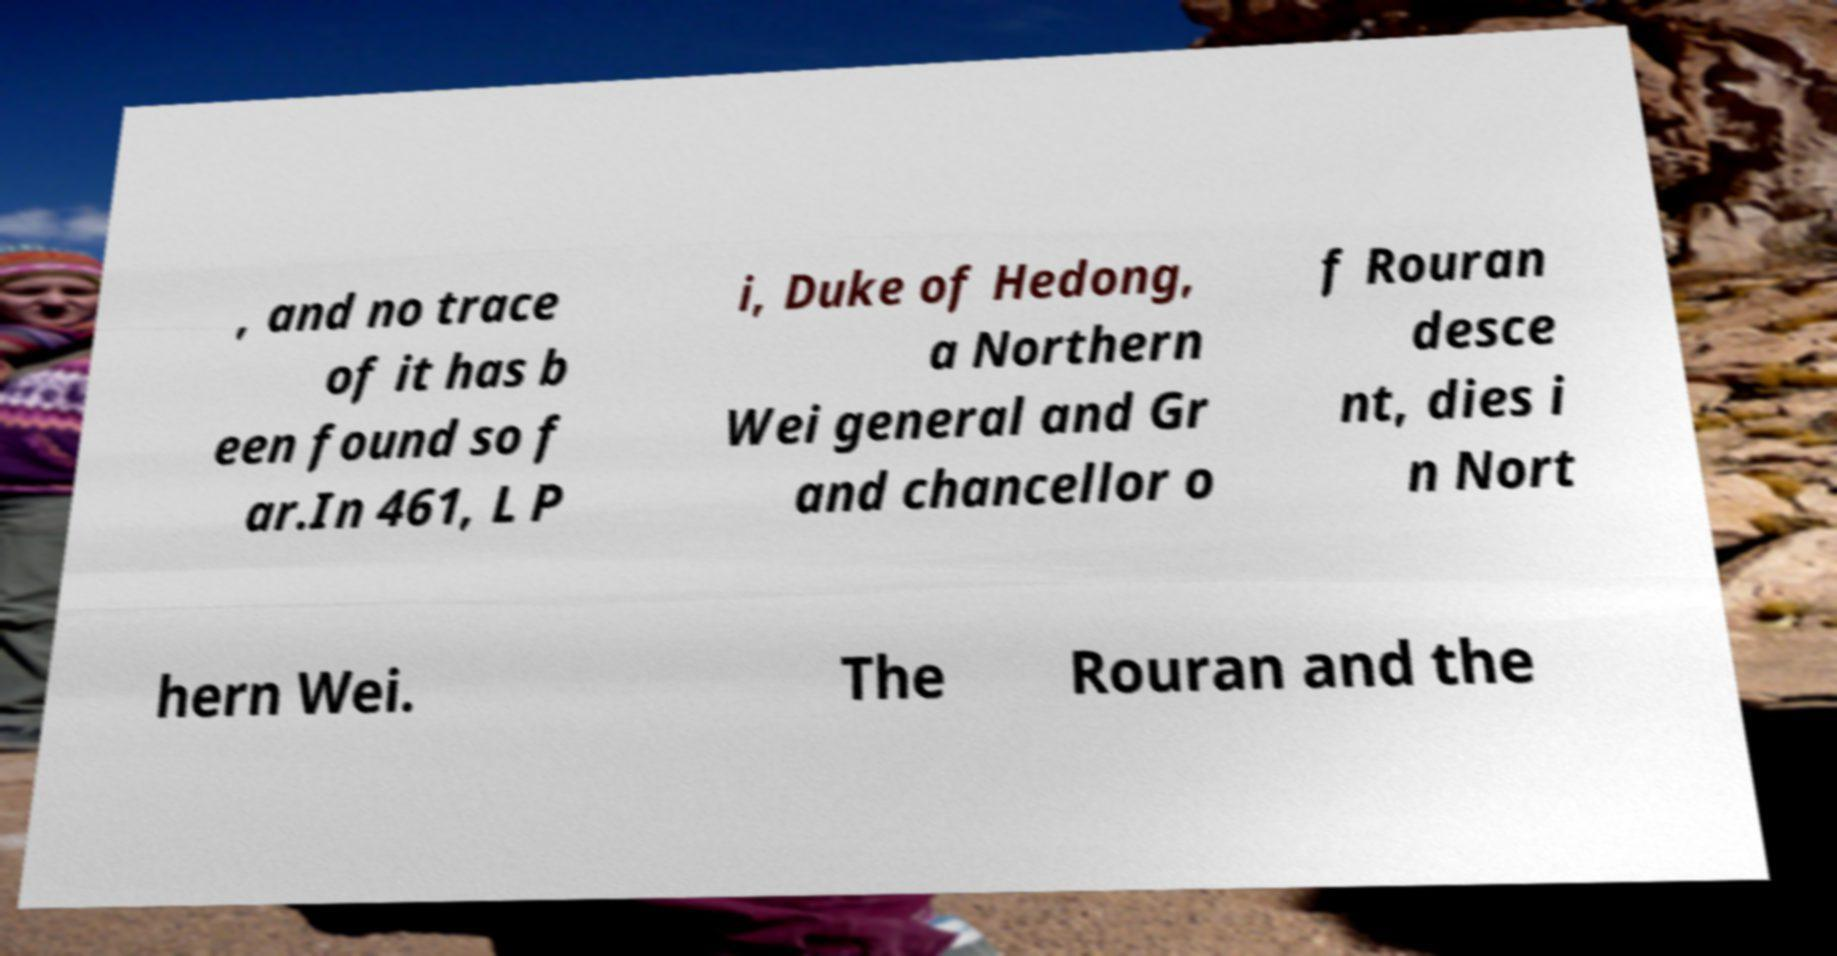Could you extract and type out the text from this image? , and no trace of it has b een found so f ar.In 461, L P i, Duke of Hedong, a Northern Wei general and Gr and chancellor o f Rouran desce nt, dies i n Nort hern Wei. The Rouran and the 